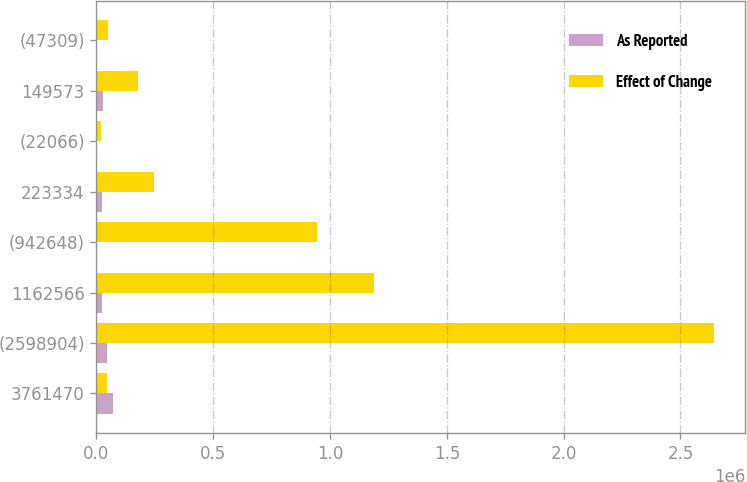Convert chart to OTSL. <chart><loc_0><loc_0><loc_500><loc_500><stacked_bar_chart><ecel><fcel>3761470<fcel>(2598904)<fcel>1162566<fcel>(942648)<fcel>223334<fcel>(22066)<fcel>149573<fcel>(47309)<nl><fcel>As Reported<fcel>71196<fcel>45926<fcel>25270<fcel>1066<fcel>24204<fcel>2497<fcel>26701<fcel>3915<nl><fcel>Effect of Change<fcel>45926<fcel>2.64483e+06<fcel>1.18784e+06<fcel>943714<fcel>247538<fcel>19569<fcel>176274<fcel>51224<nl></chart> 